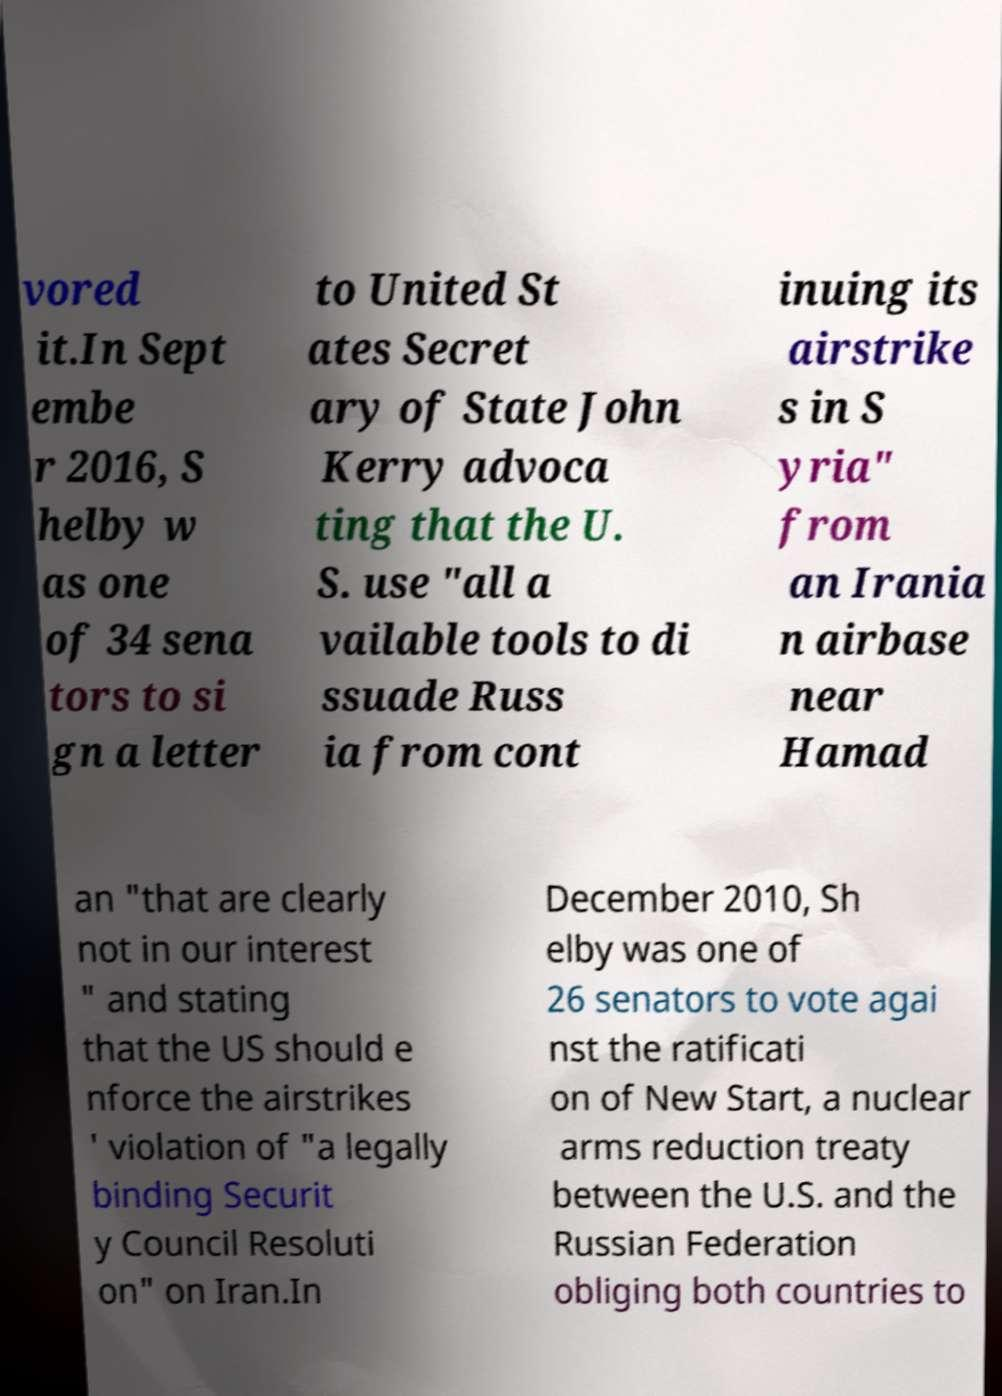Please identify and transcribe the text found in this image. vored it.In Sept embe r 2016, S helby w as one of 34 sena tors to si gn a letter to United St ates Secret ary of State John Kerry advoca ting that the U. S. use "all a vailable tools to di ssuade Russ ia from cont inuing its airstrike s in S yria" from an Irania n airbase near Hamad an "that are clearly not in our interest " and stating that the US should e nforce the airstrikes ' violation of "a legally binding Securit y Council Resoluti on" on Iran.In December 2010, Sh elby was one of 26 senators to vote agai nst the ratificati on of New Start, a nuclear arms reduction treaty between the U.S. and the Russian Federation obliging both countries to 